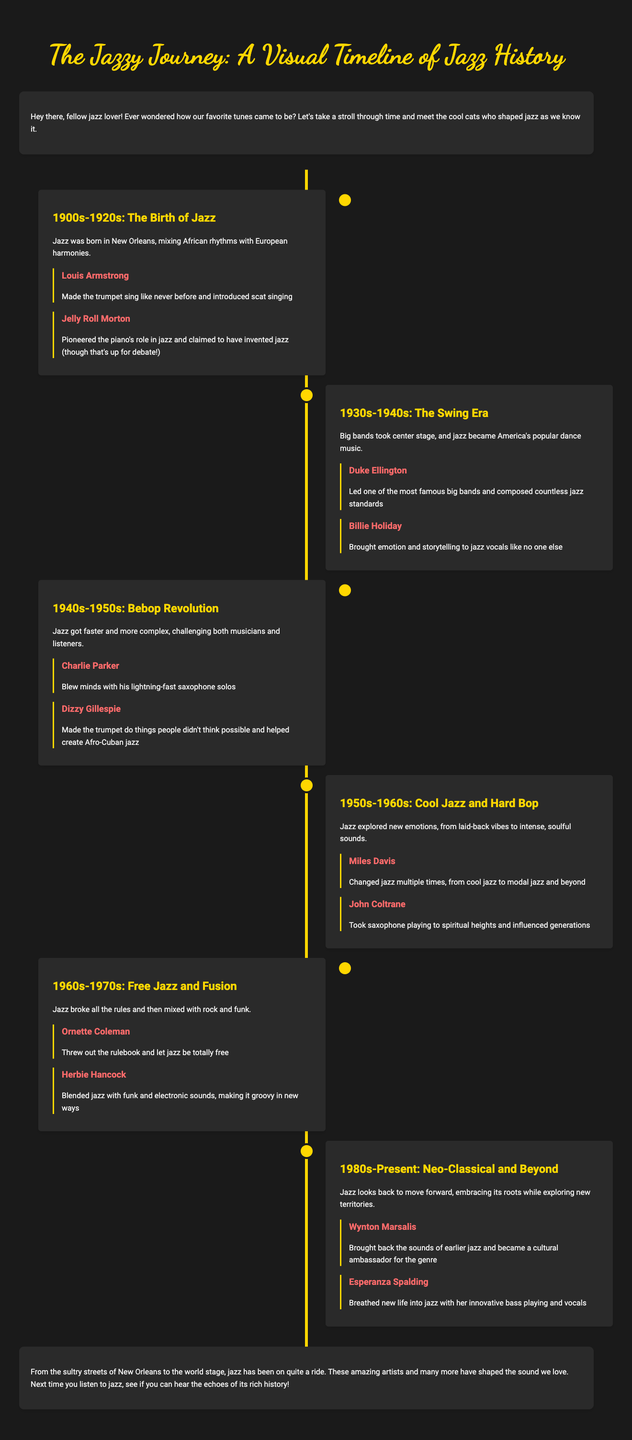What era marks the beginning of jazz? The document specifies the era of "1900s-1920s" as the birth of jazz.
Answer: 1900s-1920s Who was known for introducing scat singing? The document mentions Louis Armstrong as the artist who introduced scat singing.
Answer: Louis Armstrong Which artist is associated with the term "Bebop Revolution"? The timeline lists Charlie Parker as a key artist during the Bebop Revolution.
Answer: Charlie Parker What contribution did Billie Holiday make to jazz? The brochure states that Billie Holiday brought emotion and storytelling to jazz vocals.
Answer: Emotion and storytelling What colorful scheme is suggested for the visual elements? The document describes a vibrant, warm color palette reminiscent of jazz club atmospheres.
Answer: Vibrant, warm color palette How many eras are showcased in the timeline? The document lists six distinct eras of jazz history.
Answer: Six What innovation is linked to Herbie Hancock? The document attributes the blending of jazz with funk and electronic sounds to Herbie Hancock.
Answer: Blended jazz with funk and electronic sounds Which artist is recognized for taking saxophone playing to spiritual heights? The brochure highlights John Coltrane as having taken saxophone playing to spiritual heights.
Answer: John Coltrane What visual element represents different artists and eras? The document refers to using simple, colorful icons of instruments for visual representation.
Answer: Instrument Icons 